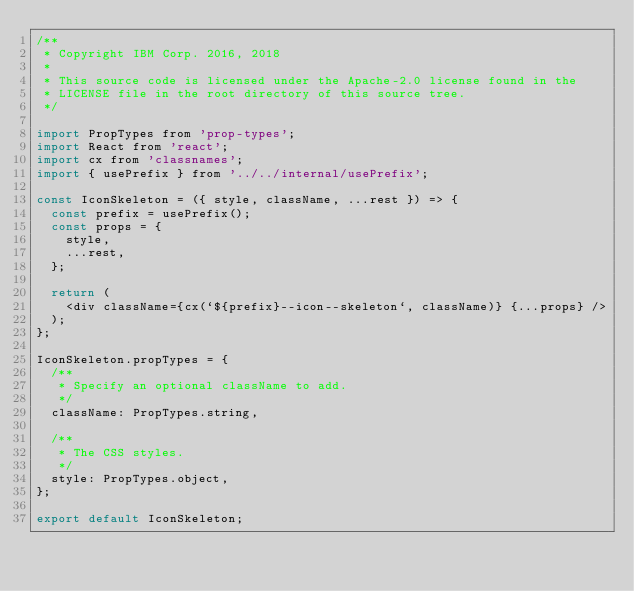Convert code to text. <code><loc_0><loc_0><loc_500><loc_500><_JavaScript_>/**
 * Copyright IBM Corp. 2016, 2018
 *
 * This source code is licensed under the Apache-2.0 license found in the
 * LICENSE file in the root directory of this source tree.
 */

import PropTypes from 'prop-types';
import React from 'react';
import cx from 'classnames';
import { usePrefix } from '../../internal/usePrefix';

const IconSkeleton = ({ style, className, ...rest }) => {
  const prefix = usePrefix();
  const props = {
    style,
    ...rest,
  };

  return (
    <div className={cx(`${prefix}--icon--skeleton`, className)} {...props} />
  );
};

IconSkeleton.propTypes = {
  /**
   * Specify an optional className to add.
   */
  className: PropTypes.string,

  /**
   * The CSS styles.
   */
  style: PropTypes.object,
};

export default IconSkeleton;
</code> 